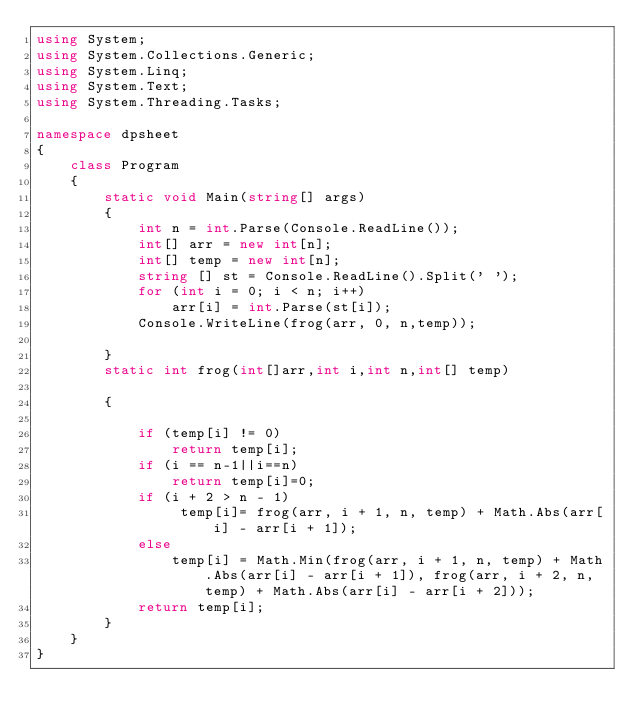<code> <loc_0><loc_0><loc_500><loc_500><_C#_>using System;
using System.Collections.Generic;
using System.Linq;
using System.Text;
using System.Threading.Tasks;

namespace dpsheet
{
    class Program
    {
        static void Main(string[] args)
        {
            int n = int.Parse(Console.ReadLine());
            int[] arr = new int[n];
            int[] temp = new int[n];
            string [] st = Console.ReadLine().Split(' ');
            for (int i = 0; i < n; i++)
                arr[i] = int.Parse(st[i]);
            Console.WriteLine(frog(arr, 0, n,temp));
             
        }
        static int frog(int[]arr,int i,int n,int[] temp)

        {

            if (temp[i] != 0)
                return temp[i];
            if (i == n-1||i==n)
                return temp[i]=0;
            if (i + 2 > n - 1)
                 temp[i]= frog(arr, i + 1, n, temp) + Math.Abs(arr[i] - arr[i + 1]);
            else
                temp[i] = Math.Min(frog(arr, i + 1, n, temp) + Math.Abs(arr[i] - arr[i + 1]), frog(arr, i + 2, n, temp) + Math.Abs(arr[i] - arr[i + 2]));
            return temp[i];
        }
    }
}
</code> 